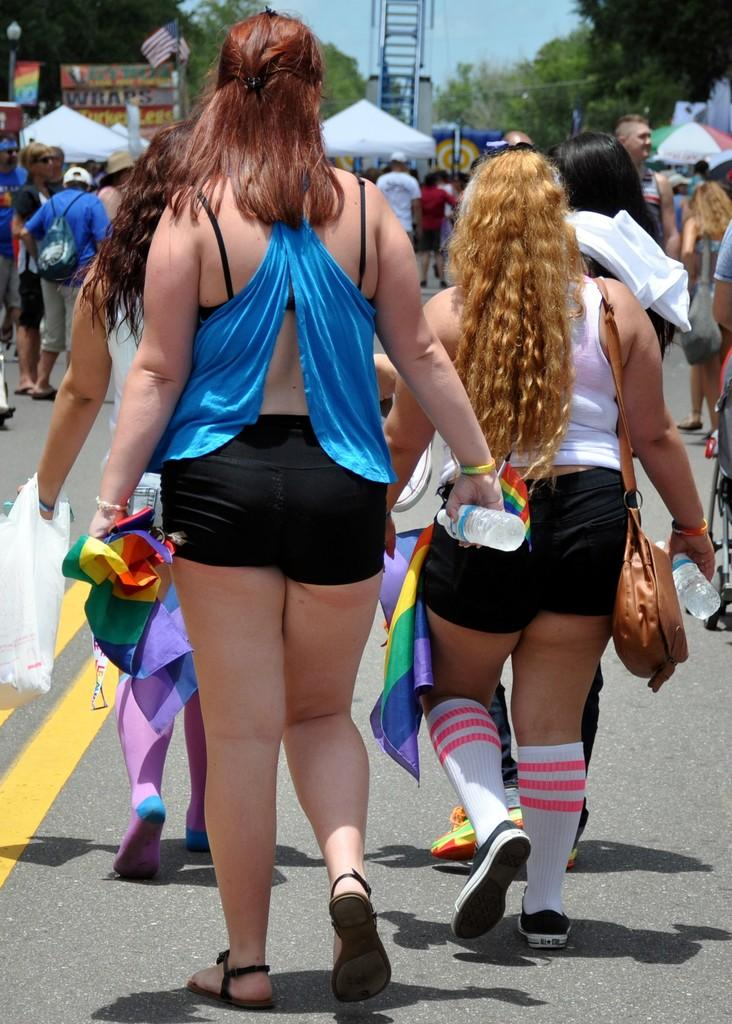What is happening on the road in the image? There are people on the road in the image. What can be seen in the background of the image? There are tents and trees visible in the background of the image. What is written or displayed on the board in the image? There is a board with text in the image. What is visible in the sky in the image? The sky is visible in the image. How many clocks are hanging from the trees in the image? There are no clocks hanging from the trees in the image. What type of scarf is being used to turn the tents in the image? There is no scarf or turning of tents depicted in the image. 